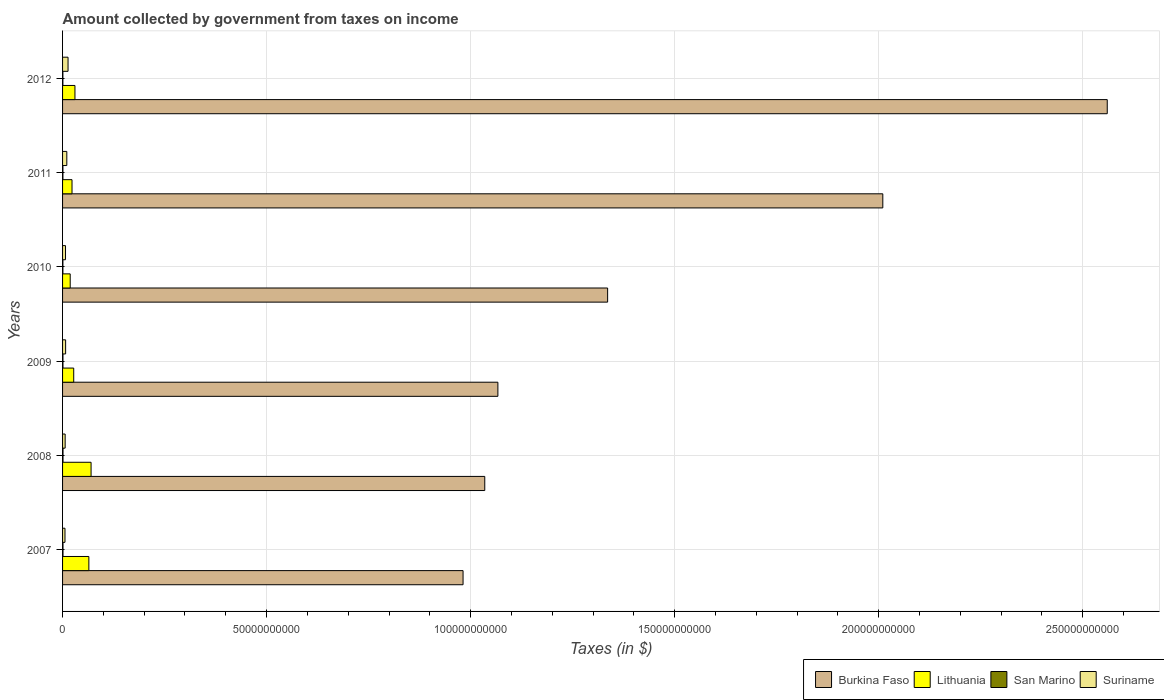How many groups of bars are there?
Your answer should be very brief. 6. In how many cases, is the number of bars for a given year not equal to the number of legend labels?
Make the answer very short. 0. What is the amount collected by government from taxes on income in Suriname in 2009?
Ensure brevity in your answer.  7.49e+08. Across all years, what is the maximum amount collected by government from taxes on income in Lithuania?
Ensure brevity in your answer.  6.99e+09. Across all years, what is the minimum amount collected by government from taxes on income in San Marino?
Provide a succinct answer. 8.07e+07. In which year was the amount collected by government from taxes on income in Burkina Faso maximum?
Provide a short and direct response. 2012. What is the total amount collected by government from taxes on income in Suriname in the graph?
Your answer should be very brief. 5.09e+09. What is the difference between the amount collected by government from taxes on income in San Marino in 2009 and that in 2012?
Provide a succinct answer. 1.73e+07. What is the difference between the amount collected by government from taxes on income in Burkina Faso in 2009 and the amount collected by government from taxes on income in Lithuania in 2011?
Your answer should be compact. 1.04e+11. What is the average amount collected by government from taxes on income in San Marino per year?
Give a very brief answer. 9.41e+07. In the year 2007, what is the difference between the amount collected by government from taxes on income in Lithuania and amount collected by government from taxes on income in Suriname?
Your answer should be compact. 5.85e+09. In how many years, is the amount collected by government from taxes on income in Burkina Faso greater than 190000000000 $?
Ensure brevity in your answer.  2. What is the ratio of the amount collected by government from taxes on income in San Marino in 2008 to that in 2011?
Your answer should be compact. 1.24. What is the difference between the highest and the second highest amount collected by government from taxes on income in San Marino?
Offer a very short reply. 3.65e+06. What is the difference between the highest and the lowest amount collected by government from taxes on income in Burkina Faso?
Make the answer very short. 1.58e+11. Is it the case that in every year, the sum of the amount collected by government from taxes on income in Lithuania and amount collected by government from taxes on income in San Marino is greater than the sum of amount collected by government from taxes on income in Suriname and amount collected by government from taxes on income in Burkina Faso?
Ensure brevity in your answer.  Yes. What does the 4th bar from the top in 2011 represents?
Offer a very short reply. Burkina Faso. What does the 4th bar from the bottom in 2011 represents?
Your response must be concise. Suriname. How many bars are there?
Offer a very short reply. 24. Are all the bars in the graph horizontal?
Your response must be concise. Yes. Are the values on the major ticks of X-axis written in scientific E-notation?
Keep it short and to the point. No. Does the graph contain any zero values?
Give a very brief answer. No. How many legend labels are there?
Provide a short and direct response. 4. What is the title of the graph?
Ensure brevity in your answer.  Amount collected by government from taxes on income. What is the label or title of the X-axis?
Ensure brevity in your answer.  Taxes (in $). What is the Taxes (in $) of Burkina Faso in 2007?
Make the answer very short. 9.82e+1. What is the Taxes (in $) of Lithuania in 2007?
Offer a terse response. 6.44e+09. What is the Taxes (in $) of San Marino in 2007?
Provide a short and direct response. 1.06e+08. What is the Taxes (in $) of Suriname in 2007?
Your answer should be very brief. 5.95e+08. What is the Taxes (in $) in Burkina Faso in 2008?
Your response must be concise. 1.03e+11. What is the Taxes (in $) in Lithuania in 2008?
Ensure brevity in your answer.  6.99e+09. What is the Taxes (in $) in San Marino in 2008?
Ensure brevity in your answer.  1.09e+08. What is the Taxes (in $) in Suriname in 2008?
Make the answer very short. 6.34e+08. What is the Taxes (in $) in Burkina Faso in 2009?
Offer a terse response. 1.07e+11. What is the Taxes (in $) in Lithuania in 2009?
Your answer should be compact. 2.73e+09. What is the Taxes (in $) of San Marino in 2009?
Offer a terse response. 9.80e+07. What is the Taxes (in $) of Suriname in 2009?
Offer a very short reply. 7.49e+08. What is the Taxes (in $) of Burkina Faso in 2010?
Your answer should be very brief. 1.34e+11. What is the Taxes (in $) in Lithuania in 2010?
Your answer should be very brief. 1.87e+09. What is the Taxes (in $) of San Marino in 2010?
Provide a succinct answer. 8.28e+07. What is the Taxes (in $) of Suriname in 2010?
Provide a succinct answer. 7.22e+08. What is the Taxes (in $) of Burkina Faso in 2011?
Your answer should be compact. 2.01e+11. What is the Taxes (in $) in Lithuania in 2011?
Give a very brief answer. 2.32e+09. What is the Taxes (in $) in San Marino in 2011?
Your answer should be very brief. 8.82e+07. What is the Taxes (in $) of Suriname in 2011?
Your response must be concise. 1.04e+09. What is the Taxes (in $) of Burkina Faso in 2012?
Provide a succinct answer. 2.56e+11. What is the Taxes (in $) in Lithuania in 2012?
Your answer should be compact. 3.04e+09. What is the Taxes (in $) in San Marino in 2012?
Provide a short and direct response. 8.07e+07. What is the Taxes (in $) of Suriname in 2012?
Your response must be concise. 1.34e+09. Across all years, what is the maximum Taxes (in $) of Burkina Faso?
Keep it short and to the point. 2.56e+11. Across all years, what is the maximum Taxes (in $) in Lithuania?
Give a very brief answer. 6.99e+09. Across all years, what is the maximum Taxes (in $) of San Marino?
Your response must be concise. 1.09e+08. Across all years, what is the maximum Taxes (in $) in Suriname?
Give a very brief answer. 1.34e+09. Across all years, what is the minimum Taxes (in $) of Burkina Faso?
Your response must be concise. 9.82e+1. Across all years, what is the minimum Taxes (in $) of Lithuania?
Provide a short and direct response. 1.87e+09. Across all years, what is the minimum Taxes (in $) of San Marino?
Keep it short and to the point. 8.07e+07. Across all years, what is the minimum Taxes (in $) in Suriname?
Provide a short and direct response. 5.95e+08. What is the total Taxes (in $) of Burkina Faso in the graph?
Your answer should be compact. 8.99e+11. What is the total Taxes (in $) of Lithuania in the graph?
Offer a terse response. 2.34e+1. What is the total Taxes (in $) in San Marino in the graph?
Your response must be concise. 5.64e+08. What is the total Taxes (in $) in Suriname in the graph?
Your answer should be compact. 5.09e+09. What is the difference between the Taxes (in $) of Burkina Faso in 2007 and that in 2008?
Provide a succinct answer. -5.32e+09. What is the difference between the Taxes (in $) in Lithuania in 2007 and that in 2008?
Give a very brief answer. -5.42e+08. What is the difference between the Taxes (in $) of San Marino in 2007 and that in 2008?
Offer a terse response. -3.65e+06. What is the difference between the Taxes (in $) of Suriname in 2007 and that in 2008?
Make the answer very short. -3.89e+07. What is the difference between the Taxes (in $) in Burkina Faso in 2007 and that in 2009?
Provide a succinct answer. -8.54e+09. What is the difference between the Taxes (in $) of Lithuania in 2007 and that in 2009?
Give a very brief answer. 3.71e+09. What is the difference between the Taxes (in $) of San Marino in 2007 and that in 2009?
Offer a terse response. 7.55e+06. What is the difference between the Taxes (in $) in Suriname in 2007 and that in 2009?
Provide a short and direct response. -1.55e+08. What is the difference between the Taxes (in $) in Burkina Faso in 2007 and that in 2010?
Your answer should be very brief. -3.54e+1. What is the difference between the Taxes (in $) of Lithuania in 2007 and that in 2010?
Your answer should be very brief. 4.57e+09. What is the difference between the Taxes (in $) of San Marino in 2007 and that in 2010?
Your answer should be very brief. 2.27e+07. What is the difference between the Taxes (in $) in Suriname in 2007 and that in 2010?
Your response must be concise. -1.28e+08. What is the difference between the Taxes (in $) in Burkina Faso in 2007 and that in 2011?
Ensure brevity in your answer.  -1.03e+11. What is the difference between the Taxes (in $) of Lithuania in 2007 and that in 2011?
Your response must be concise. 4.13e+09. What is the difference between the Taxes (in $) of San Marino in 2007 and that in 2011?
Keep it short and to the point. 1.73e+07. What is the difference between the Taxes (in $) in Suriname in 2007 and that in 2011?
Make the answer very short. -4.46e+08. What is the difference between the Taxes (in $) of Burkina Faso in 2007 and that in 2012?
Make the answer very short. -1.58e+11. What is the difference between the Taxes (in $) of Lithuania in 2007 and that in 2012?
Your response must be concise. 3.41e+09. What is the difference between the Taxes (in $) of San Marino in 2007 and that in 2012?
Ensure brevity in your answer.  2.48e+07. What is the difference between the Taxes (in $) of Suriname in 2007 and that in 2012?
Offer a terse response. -7.50e+08. What is the difference between the Taxes (in $) in Burkina Faso in 2008 and that in 2009?
Your response must be concise. -3.22e+09. What is the difference between the Taxes (in $) of Lithuania in 2008 and that in 2009?
Give a very brief answer. 4.25e+09. What is the difference between the Taxes (in $) in San Marino in 2008 and that in 2009?
Ensure brevity in your answer.  1.12e+07. What is the difference between the Taxes (in $) of Suriname in 2008 and that in 2009?
Your answer should be compact. -1.16e+08. What is the difference between the Taxes (in $) of Burkina Faso in 2008 and that in 2010?
Provide a succinct answer. -3.01e+1. What is the difference between the Taxes (in $) of Lithuania in 2008 and that in 2010?
Ensure brevity in your answer.  5.12e+09. What is the difference between the Taxes (in $) of San Marino in 2008 and that in 2010?
Your response must be concise. 2.64e+07. What is the difference between the Taxes (in $) in Suriname in 2008 and that in 2010?
Your answer should be compact. -8.88e+07. What is the difference between the Taxes (in $) of Burkina Faso in 2008 and that in 2011?
Offer a very short reply. -9.76e+1. What is the difference between the Taxes (in $) of Lithuania in 2008 and that in 2011?
Provide a short and direct response. 4.67e+09. What is the difference between the Taxes (in $) in San Marino in 2008 and that in 2011?
Provide a succinct answer. 2.10e+07. What is the difference between the Taxes (in $) in Suriname in 2008 and that in 2011?
Make the answer very short. -4.07e+08. What is the difference between the Taxes (in $) in Burkina Faso in 2008 and that in 2012?
Your answer should be very brief. -1.53e+11. What is the difference between the Taxes (in $) in Lithuania in 2008 and that in 2012?
Provide a succinct answer. 3.95e+09. What is the difference between the Taxes (in $) in San Marino in 2008 and that in 2012?
Make the answer very short. 2.85e+07. What is the difference between the Taxes (in $) of Suriname in 2008 and that in 2012?
Offer a very short reply. -7.11e+08. What is the difference between the Taxes (in $) in Burkina Faso in 2009 and that in 2010?
Your response must be concise. -2.69e+1. What is the difference between the Taxes (in $) of Lithuania in 2009 and that in 2010?
Offer a terse response. 8.62e+08. What is the difference between the Taxes (in $) of San Marino in 2009 and that in 2010?
Keep it short and to the point. 1.52e+07. What is the difference between the Taxes (in $) of Suriname in 2009 and that in 2010?
Your answer should be compact. 2.70e+07. What is the difference between the Taxes (in $) of Burkina Faso in 2009 and that in 2011?
Your response must be concise. -9.43e+1. What is the difference between the Taxes (in $) of Lithuania in 2009 and that in 2011?
Ensure brevity in your answer.  4.16e+08. What is the difference between the Taxes (in $) in San Marino in 2009 and that in 2011?
Your answer should be compact. 9.79e+06. What is the difference between the Taxes (in $) in Suriname in 2009 and that in 2011?
Give a very brief answer. -2.91e+08. What is the difference between the Taxes (in $) of Burkina Faso in 2009 and that in 2012?
Your answer should be very brief. -1.49e+11. What is the difference between the Taxes (in $) of Lithuania in 2009 and that in 2012?
Provide a succinct answer. -3.05e+08. What is the difference between the Taxes (in $) in San Marino in 2009 and that in 2012?
Provide a short and direct response. 1.73e+07. What is the difference between the Taxes (in $) of Suriname in 2009 and that in 2012?
Make the answer very short. -5.95e+08. What is the difference between the Taxes (in $) of Burkina Faso in 2010 and that in 2011?
Provide a short and direct response. -6.74e+1. What is the difference between the Taxes (in $) in Lithuania in 2010 and that in 2011?
Give a very brief answer. -4.46e+08. What is the difference between the Taxes (in $) of San Marino in 2010 and that in 2011?
Offer a very short reply. -5.37e+06. What is the difference between the Taxes (in $) of Suriname in 2010 and that in 2011?
Offer a terse response. -3.18e+08. What is the difference between the Taxes (in $) of Burkina Faso in 2010 and that in 2012?
Your answer should be very brief. -1.22e+11. What is the difference between the Taxes (in $) in Lithuania in 2010 and that in 2012?
Your response must be concise. -1.17e+09. What is the difference between the Taxes (in $) of San Marino in 2010 and that in 2012?
Make the answer very short. 2.12e+06. What is the difference between the Taxes (in $) in Suriname in 2010 and that in 2012?
Provide a short and direct response. -6.23e+08. What is the difference between the Taxes (in $) of Burkina Faso in 2011 and that in 2012?
Make the answer very short. -5.50e+1. What is the difference between the Taxes (in $) of Lithuania in 2011 and that in 2012?
Make the answer very short. -7.20e+08. What is the difference between the Taxes (in $) in San Marino in 2011 and that in 2012?
Your answer should be very brief. 7.49e+06. What is the difference between the Taxes (in $) in Suriname in 2011 and that in 2012?
Provide a short and direct response. -3.04e+08. What is the difference between the Taxes (in $) in Burkina Faso in 2007 and the Taxes (in $) in Lithuania in 2008?
Provide a short and direct response. 9.12e+1. What is the difference between the Taxes (in $) in Burkina Faso in 2007 and the Taxes (in $) in San Marino in 2008?
Ensure brevity in your answer.  9.80e+1. What is the difference between the Taxes (in $) in Burkina Faso in 2007 and the Taxes (in $) in Suriname in 2008?
Offer a very short reply. 9.75e+1. What is the difference between the Taxes (in $) of Lithuania in 2007 and the Taxes (in $) of San Marino in 2008?
Give a very brief answer. 6.34e+09. What is the difference between the Taxes (in $) in Lithuania in 2007 and the Taxes (in $) in Suriname in 2008?
Your response must be concise. 5.81e+09. What is the difference between the Taxes (in $) in San Marino in 2007 and the Taxes (in $) in Suriname in 2008?
Give a very brief answer. -5.28e+08. What is the difference between the Taxes (in $) in Burkina Faso in 2007 and the Taxes (in $) in Lithuania in 2009?
Provide a short and direct response. 9.54e+1. What is the difference between the Taxes (in $) in Burkina Faso in 2007 and the Taxes (in $) in San Marino in 2009?
Your response must be concise. 9.81e+1. What is the difference between the Taxes (in $) of Burkina Faso in 2007 and the Taxes (in $) of Suriname in 2009?
Your answer should be compact. 9.74e+1. What is the difference between the Taxes (in $) of Lithuania in 2007 and the Taxes (in $) of San Marino in 2009?
Offer a terse response. 6.35e+09. What is the difference between the Taxes (in $) in Lithuania in 2007 and the Taxes (in $) in Suriname in 2009?
Your answer should be very brief. 5.70e+09. What is the difference between the Taxes (in $) in San Marino in 2007 and the Taxes (in $) in Suriname in 2009?
Ensure brevity in your answer.  -6.44e+08. What is the difference between the Taxes (in $) of Burkina Faso in 2007 and the Taxes (in $) of Lithuania in 2010?
Offer a very short reply. 9.63e+1. What is the difference between the Taxes (in $) in Burkina Faso in 2007 and the Taxes (in $) in San Marino in 2010?
Offer a very short reply. 9.81e+1. What is the difference between the Taxes (in $) in Burkina Faso in 2007 and the Taxes (in $) in Suriname in 2010?
Keep it short and to the point. 9.74e+1. What is the difference between the Taxes (in $) in Lithuania in 2007 and the Taxes (in $) in San Marino in 2010?
Offer a terse response. 6.36e+09. What is the difference between the Taxes (in $) of Lithuania in 2007 and the Taxes (in $) of Suriname in 2010?
Give a very brief answer. 5.72e+09. What is the difference between the Taxes (in $) of San Marino in 2007 and the Taxes (in $) of Suriname in 2010?
Give a very brief answer. -6.17e+08. What is the difference between the Taxes (in $) of Burkina Faso in 2007 and the Taxes (in $) of Lithuania in 2011?
Your answer should be compact. 9.58e+1. What is the difference between the Taxes (in $) in Burkina Faso in 2007 and the Taxes (in $) in San Marino in 2011?
Provide a succinct answer. 9.81e+1. What is the difference between the Taxes (in $) of Burkina Faso in 2007 and the Taxes (in $) of Suriname in 2011?
Provide a succinct answer. 9.71e+1. What is the difference between the Taxes (in $) in Lithuania in 2007 and the Taxes (in $) in San Marino in 2011?
Your answer should be compact. 6.36e+09. What is the difference between the Taxes (in $) in Lithuania in 2007 and the Taxes (in $) in Suriname in 2011?
Make the answer very short. 5.40e+09. What is the difference between the Taxes (in $) in San Marino in 2007 and the Taxes (in $) in Suriname in 2011?
Keep it short and to the point. -9.35e+08. What is the difference between the Taxes (in $) in Burkina Faso in 2007 and the Taxes (in $) in Lithuania in 2012?
Offer a terse response. 9.51e+1. What is the difference between the Taxes (in $) in Burkina Faso in 2007 and the Taxes (in $) in San Marino in 2012?
Your answer should be very brief. 9.81e+1. What is the difference between the Taxes (in $) in Burkina Faso in 2007 and the Taxes (in $) in Suriname in 2012?
Ensure brevity in your answer.  9.68e+1. What is the difference between the Taxes (in $) of Lithuania in 2007 and the Taxes (in $) of San Marino in 2012?
Offer a terse response. 6.36e+09. What is the difference between the Taxes (in $) of Lithuania in 2007 and the Taxes (in $) of Suriname in 2012?
Offer a terse response. 5.10e+09. What is the difference between the Taxes (in $) in San Marino in 2007 and the Taxes (in $) in Suriname in 2012?
Keep it short and to the point. -1.24e+09. What is the difference between the Taxes (in $) in Burkina Faso in 2008 and the Taxes (in $) in Lithuania in 2009?
Give a very brief answer. 1.01e+11. What is the difference between the Taxes (in $) in Burkina Faso in 2008 and the Taxes (in $) in San Marino in 2009?
Make the answer very short. 1.03e+11. What is the difference between the Taxes (in $) of Burkina Faso in 2008 and the Taxes (in $) of Suriname in 2009?
Give a very brief answer. 1.03e+11. What is the difference between the Taxes (in $) of Lithuania in 2008 and the Taxes (in $) of San Marino in 2009?
Your answer should be compact. 6.89e+09. What is the difference between the Taxes (in $) in Lithuania in 2008 and the Taxes (in $) in Suriname in 2009?
Offer a terse response. 6.24e+09. What is the difference between the Taxes (in $) of San Marino in 2008 and the Taxes (in $) of Suriname in 2009?
Your response must be concise. -6.40e+08. What is the difference between the Taxes (in $) in Burkina Faso in 2008 and the Taxes (in $) in Lithuania in 2010?
Offer a terse response. 1.02e+11. What is the difference between the Taxes (in $) in Burkina Faso in 2008 and the Taxes (in $) in San Marino in 2010?
Ensure brevity in your answer.  1.03e+11. What is the difference between the Taxes (in $) in Burkina Faso in 2008 and the Taxes (in $) in Suriname in 2010?
Your answer should be compact. 1.03e+11. What is the difference between the Taxes (in $) of Lithuania in 2008 and the Taxes (in $) of San Marino in 2010?
Your answer should be very brief. 6.90e+09. What is the difference between the Taxes (in $) of Lithuania in 2008 and the Taxes (in $) of Suriname in 2010?
Provide a short and direct response. 6.26e+09. What is the difference between the Taxes (in $) in San Marino in 2008 and the Taxes (in $) in Suriname in 2010?
Provide a short and direct response. -6.13e+08. What is the difference between the Taxes (in $) of Burkina Faso in 2008 and the Taxes (in $) of Lithuania in 2011?
Your answer should be very brief. 1.01e+11. What is the difference between the Taxes (in $) of Burkina Faso in 2008 and the Taxes (in $) of San Marino in 2011?
Give a very brief answer. 1.03e+11. What is the difference between the Taxes (in $) of Burkina Faso in 2008 and the Taxes (in $) of Suriname in 2011?
Offer a very short reply. 1.02e+11. What is the difference between the Taxes (in $) in Lithuania in 2008 and the Taxes (in $) in San Marino in 2011?
Your response must be concise. 6.90e+09. What is the difference between the Taxes (in $) of Lithuania in 2008 and the Taxes (in $) of Suriname in 2011?
Provide a succinct answer. 5.95e+09. What is the difference between the Taxes (in $) of San Marino in 2008 and the Taxes (in $) of Suriname in 2011?
Make the answer very short. -9.31e+08. What is the difference between the Taxes (in $) in Burkina Faso in 2008 and the Taxes (in $) in Lithuania in 2012?
Offer a very short reply. 1.00e+11. What is the difference between the Taxes (in $) of Burkina Faso in 2008 and the Taxes (in $) of San Marino in 2012?
Your response must be concise. 1.03e+11. What is the difference between the Taxes (in $) in Burkina Faso in 2008 and the Taxes (in $) in Suriname in 2012?
Your answer should be compact. 1.02e+11. What is the difference between the Taxes (in $) in Lithuania in 2008 and the Taxes (in $) in San Marino in 2012?
Make the answer very short. 6.91e+09. What is the difference between the Taxes (in $) of Lithuania in 2008 and the Taxes (in $) of Suriname in 2012?
Keep it short and to the point. 5.64e+09. What is the difference between the Taxes (in $) of San Marino in 2008 and the Taxes (in $) of Suriname in 2012?
Offer a terse response. -1.24e+09. What is the difference between the Taxes (in $) in Burkina Faso in 2009 and the Taxes (in $) in Lithuania in 2010?
Your response must be concise. 1.05e+11. What is the difference between the Taxes (in $) in Burkina Faso in 2009 and the Taxes (in $) in San Marino in 2010?
Offer a terse response. 1.07e+11. What is the difference between the Taxes (in $) in Burkina Faso in 2009 and the Taxes (in $) in Suriname in 2010?
Offer a terse response. 1.06e+11. What is the difference between the Taxes (in $) in Lithuania in 2009 and the Taxes (in $) in San Marino in 2010?
Ensure brevity in your answer.  2.65e+09. What is the difference between the Taxes (in $) in Lithuania in 2009 and the Taxes (in $) in Suriname in 2010?
Provide a short and direct response. 2.01e+09. What is the difference between the Taxes (in $) of San Marino in 2009 and the Taxes (in $) of Suriname in 2010?
Your answer should be very brief. -6.24e+08. What is the difference between the Taxes (in $) of Burkina Faso in 2009 and the Taxes (in $) of Lithuania in 2011?
Your response must be concise. 1.04e+11. What is the difference between the Taxes (in $) in Burkina Faso in 2009 and the Taxes (in $) in San Marino in 2011?
Offer a terse response. 1.07e+11. What is the difference between the Taxes (in $) of Burkina Faso in 2009 and the Taxes (in $) of Suriname in 2011?
Offer a terse response. 1.06e+11. What is the difference between the Taxes (in $) in Lithuania in 2009 and the Taxes (in $) in San Marino in 2011?
Your response must be concise. 2.64e+09. What is the difference between the Taxes (in $) of Lithuania in 2009 and the Taxes (in $) of Suriname in 2011?
Make the answer very short. 1.69e+09. What is the difference between the Taxes (in $) of San Marino in 2009 and the Taxes (in $) of Suriname in 2011?
Your answer should be compact. -9.42e+08. What is the difference between the Taxes (in $) in Burkina Faso in 2009 and the Taxes (in $) in Lithuania in 2012?
Offer a very short reply. 1.04e+11. What is the difference between the Taxes (in $) in Burkina Faso in 2009 and the Taxes (in $) in San Marino in 2012?
Your answer should be very brief. 1.07e+11. What is the difference between the Taxes (in $) of Burkina Faso in 2009 and the Taxes (in $) of Suriname in 2012?
Offer a terse response. 1.05e+11. What is the difference between the Taxes (in $) of Lithuania in 2009 and the Taxes (in $) of San Marino in 2012?
Make the answer very short. 2.65e+09. What is the difference between the Taxes (in $) of Lithuania in 2009 and the Taxes (in $) of Suriname in 2012?
Provide a short and direct response. 1.39e+09. What is the difference between the Taxes (in $) in San Marino in 2009 and the Taxes (in $) in Suriname in 2012?
Your response must be concise. -1.25e+09. What is the difference between the Taxes (in $) of Burkina Faso in 2010 and the Taxes (in $) of Lithuania in 2011?
Make the answer very short. 1.31e+11. What is the difference between the Taxes (in $) of Burkina Faso in 2010 and the Taxes (in $) of San Marino in 2011?
Your response must be concise. 1.33e+11. What is the difference between the Taxes (in $) of Burkina Faso in 2010 and the Taxes (in $) of Suriname in 2011?
Offer a terse response. 1.33e+11. What is the difference between the Taxes (in $) in Lithuania in 2010 and the Taxes (in $) in San Marino in 2011?
Your answer should be compact. 1.78e+09. What is the difference between the Taxes (in $) in Lithuania in 2010 and the Taxes (in $) in Suriname in 2011?
Ensure brevity in your answer.  8.30e+08. What is the difference between the Taxes (in $) in San Marino in 2010 and the Taxes (in $) in Suriname in 2011?
Your answer should be very brief. -9.58e+08. What is the difference between the Taxes (in $) in Burkina Faso in 2010 and the Taxes (in $) in Lithuania in 2012?
Provide a succinct answer. 1.31e+11. What is the difference between the Taxes (in $) of Burkina Faso in 2010 and the Taxes (in $) of San Marino in 2012?
Keep it short and to the point. 1.34e+11. What is the difference between the Taxes (in $) in Burkina Faso in 2010 and the Taxes (in $) in Suriname in 2012?
Your response must be concise. 1.32e+11. What is the difference between the Taxes (in $) of Lithuania in 2010 and the Taxes (in $) of San Marino in 2012?
Provide a short and direct response. 1.79e+09. What is the difference between the Taxes (in $) in Lithuania in 2010 and the Taxes (in $) in Suriname in 2012?
Your response must be concise. 5.26e+08. What is the difference between the Taxes (in $) of San Marino in 2010 and the Taxes (in $) of Suriname in 2012?
Provide a succinct answer. -1.26e+09. What is the difference between the Taxes (in $) in Burkina Faso in 2011 and the Taxes (in $) in Lithuania in 2012?
Ensure brevity in your answer.  1.98e+11. What is the difference between the Taxes (in $) in Burkina Faso in 2011 and the Taxes (in $) in San Marino in 2012?
Give a very brief answer. 2.01e+11. What is the difference between the Taxes (in $) in Burkina Faso in 2011 and the Taxes (in $) in Suriname in 2012?
Keep it short and to the point. 2.00e+11. What is the difference between the Taxes (in $) in Lithuania in 2011 and the Taxes (in $) in San Marino in 2012?
Your answer should be very brief. 2.24e+09. What is the difference between the Taxes (in $) in Lithuania in 2011 and the Taxes (in $) in Suriname in 2012?
Provide a short and direct response. 9.72e+08. What is the difference between the Taxes (in $) of San Marino in 2011 and the Taxes (in $) of Suriname in 2012?
Offer a very short reply. -1.26e+09. What is the average Taxes (in $) in Burkina Faso per year?
Provide a short and direct response. 1.50e+11. What is the average Taxes (in $) of Lithuania per year?
Ensure brevity in your answer.  3.90e+09. What is the average Taxes (in $) of San Marino per year?
Your response must be concise. 9.41e+07. What is the average Taxes (in $) in Suriname per year?
Keep it short and to the point. 8.48e+08. In the year 2007, what is the difference between the Taxes (in $) in Burkina Faso and Taxes (in $) in Lithuania?
Give a very brief answer. 9.17e+1. In the year 2007, what is the difference between the Taxes (in $) in Burkina Faso and Taxes (in $) in San Marino?
Offer a very short reply. 9.80e+1. In the year 2007, what is the difference between the Taxes (in $) in Burkina Faso and Taxes (in $) in Suriname?
Provide a succinct answer. 9.76e+1. In the year 2007, what is the difference between the Taxes (in $) of Lithuania and Taxes (in $) of San Marino?
Provide a short and direct response. 6.34e+09. In the year 2007, what is the difference between the Taxes (in $) in Lithuania and Taxes (in $) in Suriname?
Keep it short and to the point. 5.85e+09. In the year 2007, what is the difference between the Taxes (in $) of San Marino and Taxes (in $) of Suriname?
Give a very brief answer. -4.89e+08. In the year 2008, what is the difference between the Taxes (in $) in Burkina Faso and Taxes (in $) in Lithuania?
Keep it short and to the point. 9.65e+1. In the year 2008, what is the difference between the Taxes (in $) in Burkina Faso and Taxes (in $) in San Marino?
Your response must be concise. 1.03e+11. In the year 2008, what is the difference between the Taxes (in $) of Burkina Faso and Taxes (in $) of Suriname?
Your answer should be compact. 1.03e+11. In the year 2008, what is the difference between the Taxes (in $) in Lithuania and Taxes (in $) in San Marino?
Keep it short and to the point. 6.88e+09. In the year 2008, what is the difference between the Taxes (in $) in Lithuania and Taxes (in $) in Suriname?
Your answer should be compact. 6.35e+09. In the year 2008, what is the difference between the Taxes (in $) of San Marino and Taxes (in $) of Suriname?
Your response must be concise. -5.24e+08. In the year 2009, what is the difference between the Taxes (in $) in Burkina Faso and Taxes (in $) in Lithuania?
Offer a very short reply. 1.04e+11. In the year 2009, what is the difference between the Taxes (in $) in Burkina Faso and Taxes (in $) in San Marino?
Provide a succinct answer. 1.07e+11. In the year 2009, what is the difference between the Taxes (in $) in Burkina Faso and Taxes (in $) in Suriname?
Make the answer very short. 1.06e+11. In the year 2009, what is the difference between the Taxes (in $) in Lithuania and Taxes (in $) in San Marino?
Keep it short and to the point. 2.63e+09. In the year 2009, what is the difference between the Taxes (in $) of Lithuania and Taxes (in $) of Suriname?
Keep it short and to the point. 1.98e+09. In the year 2009, what is the difference between the Taxes (in $) of San Marino and Taxes (in $) of Suriname?
Make the answer very short. -6.51e+08. In the year 2010, what is the difference between the Taxes (in $) of Burkina Faso and Taxes (in $) of Lithuania?
Provide a succinct answer. 1.32e+11. In the year 2010, what is the difference between the Taxes (in $) of Burkina Faso and Taxes (in $) of San Marino?
Provide a short and direct response. 1.33e+11. In the year 2010, what is the difference between the Taxes (in $) in Burkina Faso and Taxes (in $) in Suriname?
Your response must be concise. 1.33e+11. In the year 2010, what is the difference between the Taxes (in $) in Lithuania and Taxes (in $) in San Marino?
Give a very brief answer. 1.79e+09. In the year 2010, what is the difference between the Taxes (in $) in Lithuania and Taxes (in $) in Suriname?
Give a very brief answer. 1.15e+09. In the year 2010, what is the difference between the Taxes (in $) in San Marino and Taxes (in $) in Suriname?
Give a very brief answer. -6.39e+08. In the year 2011, what is the difference between the Taxes (in $) in Burkina Faso and Taxes (in $) in Lithuania?
Offer a very short reply. 1.99e+11. In the year 2011, what is the difference between the Taxes (in $) in Burkina Faso and Taxes (in $) in San Marino?
Give a very brief answer. 2.01e+11. In the year 2011, what is the difference between the Taxes (in $) of Burkina Faso and Taxes (in $) of Suriname?
Make the answer very short. 2.00e+11. In the year 2011, what is the difference between the Taxes (in $) in Lithuania and Taxes (in $) in San Marino?
Make the answer very short. 2.23e+09. In the year 2011, what is the difference between the Taxes (in $) in Lithuania and Taxes (in $) in Suriname?
Your response must be concise. 1.28e+09. In the year 2011, what is the difference between the Taxes (in $) in San Marino and Taxes (in $) in Suriname?
Make the answer very short. -9.52e+08. In the year 2012, what is the difference between the Taxes (in $) in Burkina Faso and Taxes (in $) in Lithuania?
Your response must be concise. 2.53e+11. In the year 2012, what is the difference between the Taxes (in $) in Burkina Faso and Taxes (in $) in San Marino?
Give a very brief answer. 2.56e+11. In the year 2012, what is the difference between the Taxes (in $) in Burkina Faso and Taxes (in $) in Suriname?
Your answer should be very brief. 2.55e+11. In the year 2012, what is the difference between the Taxes (in $) in Lithuania and Taxes (in $) in San Marino?
Ensure brevity in your answer.  2.96e+09. In the year 2012, what is the difference between the Taxes (in $) in Lithuania and Taxes (in $) in Suriname?
Your answer should be compact. 1.69e+09. In the year 2012, what is the difference between the Taxes (in $) in San Marino and Taxes (in $) in Suriname?
Your answer should be compact. -1.26e+09. What is the ratio of the Taxes (in $) in Burkina Faso in 2007 to that in 2008?
Your answer should be compact. 0.95. What is the ratio of the Taxes (in $) in Lithuania in 2007 to that in 2008?
Provide a succinct answer. 0.92. What is the ratio of the Taxes (in $) of San Marino in 2007 to that in 2008?
Offer a terse response. 0.97. What is the ratio of the Taxes (in $) of Suriname in 2007 to that in 2008?
Ensure brevity in your answer.  0.94. What is the ratio of the Taxes (in $) of Lithuania in 2007 to that in 2009?
Keep it short and to the point. 2.36. What is the ratio of the Taxes (in $) in San Marino in 2007 to that in 2009?
Offer a terse response. 1.08. What is the ratio of the Taxes (in $) in Suriname in 2007 to that in 2009?
Your answer should be compact. 0.79. What is the ratio of the Taxes (in $) in Burkina Faso in 2007 to that in 2010?
Offer a terse response. 0.73. What is the ratio of the Taxes (in $) of Lithuania in 2007 to that in 2010?
Offer a terse response. 3.45. What is the ratio of the Taxes (in $) of San Marino in 2007 to that in 2010?
Offer a terse response. 1.27. What is the ratio of the Taxes (in $) of Suriname in 2007 to that in 2010?
Keep it short and to the point. 0.82. What is the ratio of the Taxes (in $) of Burkina Faso in 2007 to that in 2011?
Ensure brevity in your answer.  0.49. What is the ratio of the Taxes (in $) of Lithuania in 2007 to that in 2011?
Provide a short and direct response. 2.78. What is the ratio of the Taxes (in $) in San Marino in 2007 to that in 2011?
Your answer should be very brief. 1.2. What is the ratio of the Taxes (in $) of Suriname in 2007 to that in 2011?
Provide a short and direct response. 0.57. What is the ratio of the Taxes (in $) of Burkina Faso in 2007 to that in 2012?
Your answer should be compact. 0.38. What is the ratio of the Taxes (in $) of Lithuania in 2007 to that in 2012?
Keep it short and to the point. 2.12. What is the ratio of the Taxes (in $) of San Marino in 2007 to that in 2012?
Keep it short and to the point. 1.31. What is the ratio of the Taxes (in $) in Suriname in 2007 to that in 2012?
Make the answer very short. 0.44. What is the ratio of the Taxes (in $) in Burkina Faso in 2008 to that in 2009?
Ensure brevity in your answer.  0.97. What is the ratio of the Taxes (in $) of Lithuania in 2008 to that in 2009?
Provide a succinct answer. 2.56. What is the ratio of the Taxes (in $) in San Marino in 2008 to that in 2009?
Your answer should be very brief. 1.11. What is the ratio of the Taxes (in $) of Suriname in 2008 to that in 2009?
Keep it short and to the point. 0.85. What is the ratio of the Taxes (in $) in Burkina Faso in 2008 to that in 2010?
Provide a succinct answer. 0.77. What is the ratio of the Taxes (in $) of Lithuania in 2008 to that in 2010?
Your answer should be compact. 3.74. What is the ratio of the Taxes (in $) of San Marino in 2008 to that in 2010?
Offer a terse response. 1.32. What is the ratio of the Taxes (in $) of Suriname in 2008 to that in 2010?
Make the answer very short. 0.88. What is the ratio of the Taxes (in $) in Burkina Faso in 2008 to that in 2011?
Offer a very short reply. 0.51. What is the ratio of the Taxes (in $) of Lithuania in 2008 to that in 2011?
Your response must be concise. 3.02. What is the ratio of the Taxes (in $) in San Marino in 2008 to that in 2011?
Ensure brevity in your answer.  1.24. What is the ratio of the Taxes (in $) of Suriname in 2008 to that in 2011?
Make the answer very short. 0.61. What is the ratio of the Taxes (in $) of Burkina Faso in 2008 to that in 2012?
Provide a succinct answer. 0.4. What is the ratio of the Taxes (in $) of Lithuania in 2008 to that in 2012?
Provide a succinct answer. 2.3. What is the ratio of the Taxes (in $) of San Marino in 2008 to that in 2012?
Offer a very short reply. 1.35. What is the ratio of the Taxes (in $) in Suriname in 2008 to that in 2012?
Make the answer very short. 0.47. What is the ratio of the Taxes (in $) in Burkina Faso in 2009 to that in 2010?
Provide a succinct answer. 0.8. What is the ratio of the Taxes (in $) in Lithuania in 2009 to that in 2010?
Your answer should be very brief. 1.46. What is the ratio of the Taxes (in $) of San Marino in 2009 to that in 2010?
Make the answer very short. 1.18. What is the ratio of the Taxes (in $) in Suriname in 2009 to that in 2010?
Make the answer very short. 1.04. What is the ratio of the Taxes (in $) in Burkina Faso in 2009 to that in 2011?
Your response must be concise. 0.53. What is the ratio of the Taxes (in $) of Lithuania in 2009 to that in 2011?
Your answer should be compact. 1.18. What is the ratio of the Taxes (in $) of San Marino in 2009 to that in 2011?
Provide a short and direct response. 1.11. What is the ratio of the Taxes (in $) in Suriname in 2009 to that in 2011?
Offer a very short reply. 0.72. What is the ratio of the Taxes (in $) of Burkina Faso in 2009 to that in 2012?
Ensure brevity in your answer.  0.42. What is the ratio of the Taxes (in $) in Lithuania in 2009 to that in 2012?
Offer a very short reply. 0.9. What is the ratio of the Taxes (in $) of San Marino in 2009 to that in 2012?
Keep it short and to the point. 1.21. What is the ratio of the Taxes (in $) of Suriname in 2009 to that in 2012?
Make the answer very short. 0.56. What is the ratio of the Taxes (in $) of Burkina Faso in 2010 to that in 2011?
Make the answer very short. 0.66. What is the ratio of the Taxes (in $) in Lithuania in 2010 to that in 2011?
Give a very brief answer. 0.81. What is the ratio of the Taxes (in $) of San Marino in 2010 to that in 2011?
Keep it short and to the point. 0.94. What is the ratio of the Taxes (in $) in Suriname in 2010 to that in 2011?
Your response must be concise. 0.69. What is the ratio of the Taxes (in $) in Burkina Faso in 2010 to that in 2012?
Your answer should be very brief. 0.52. What is the ratio of the Taxes (in $) of Lithuania in 2010 to that in 2012?
Offer a very short reply. 0.62. What is the ratio of the Taxes (in $) of San Marino in 2010 to that in 2012?
Give a very brief answer. 1.03. What is the ratio of the Taxes (in $) in Suriname in 2010 to that in 2012?
Ensure brevity in your answer.  0.54. What is the ratio of the Taxes (in $) of Burkina Faso in 2011 to that in 2012?
Offer a terse response. 0.79. What is the ratio of the Taxes (in $) in Lithuania in 2011 to that in 2012?
Give a very brief answer. 0.76. What is the ratio of the Taxes (in $) in San Marino in 2011 to that in 2012?
Provide a short and direct response. 1.09. What is the ratio of the Taxes (in $) in Suriname in 2011 to that in 2012?
Your response must be concise. 0.77. What is the difference between the highest and the second highest Taxes (in $) in Burkina Faso?
Your response must be concise. 5.50e+1. What is the difference between the highest and the second highest Taxes (in $) of Lithuania?
Make the answer very short. 5.42e+08. What is the difference between the highest and the second highest Taxes (in $) in San Marino?
Your response must be concise. 3.65e+06. What is the difference between the highest and the second highest Taxes (in $) in Suriname?
Make the answer very short. 3.04e+08. What is the difference between the highest and the lowest Taxes (in $) in Burkina Faso?
Your response must be concise. 1.58e+11. What is the difference between the highest and the lowest Taxes (in $) in Lithuania?
Provide a short and direct response. 5.12e+09. What is the difference between the highest and the lowest Taxes (in $) of San Marino?
Make the answer very short. 2.85e+07. What is the difference between the highest and the lowest Taxes (in $) of Suriname?
Ensure brevity in your answer.  7.50e+08. 